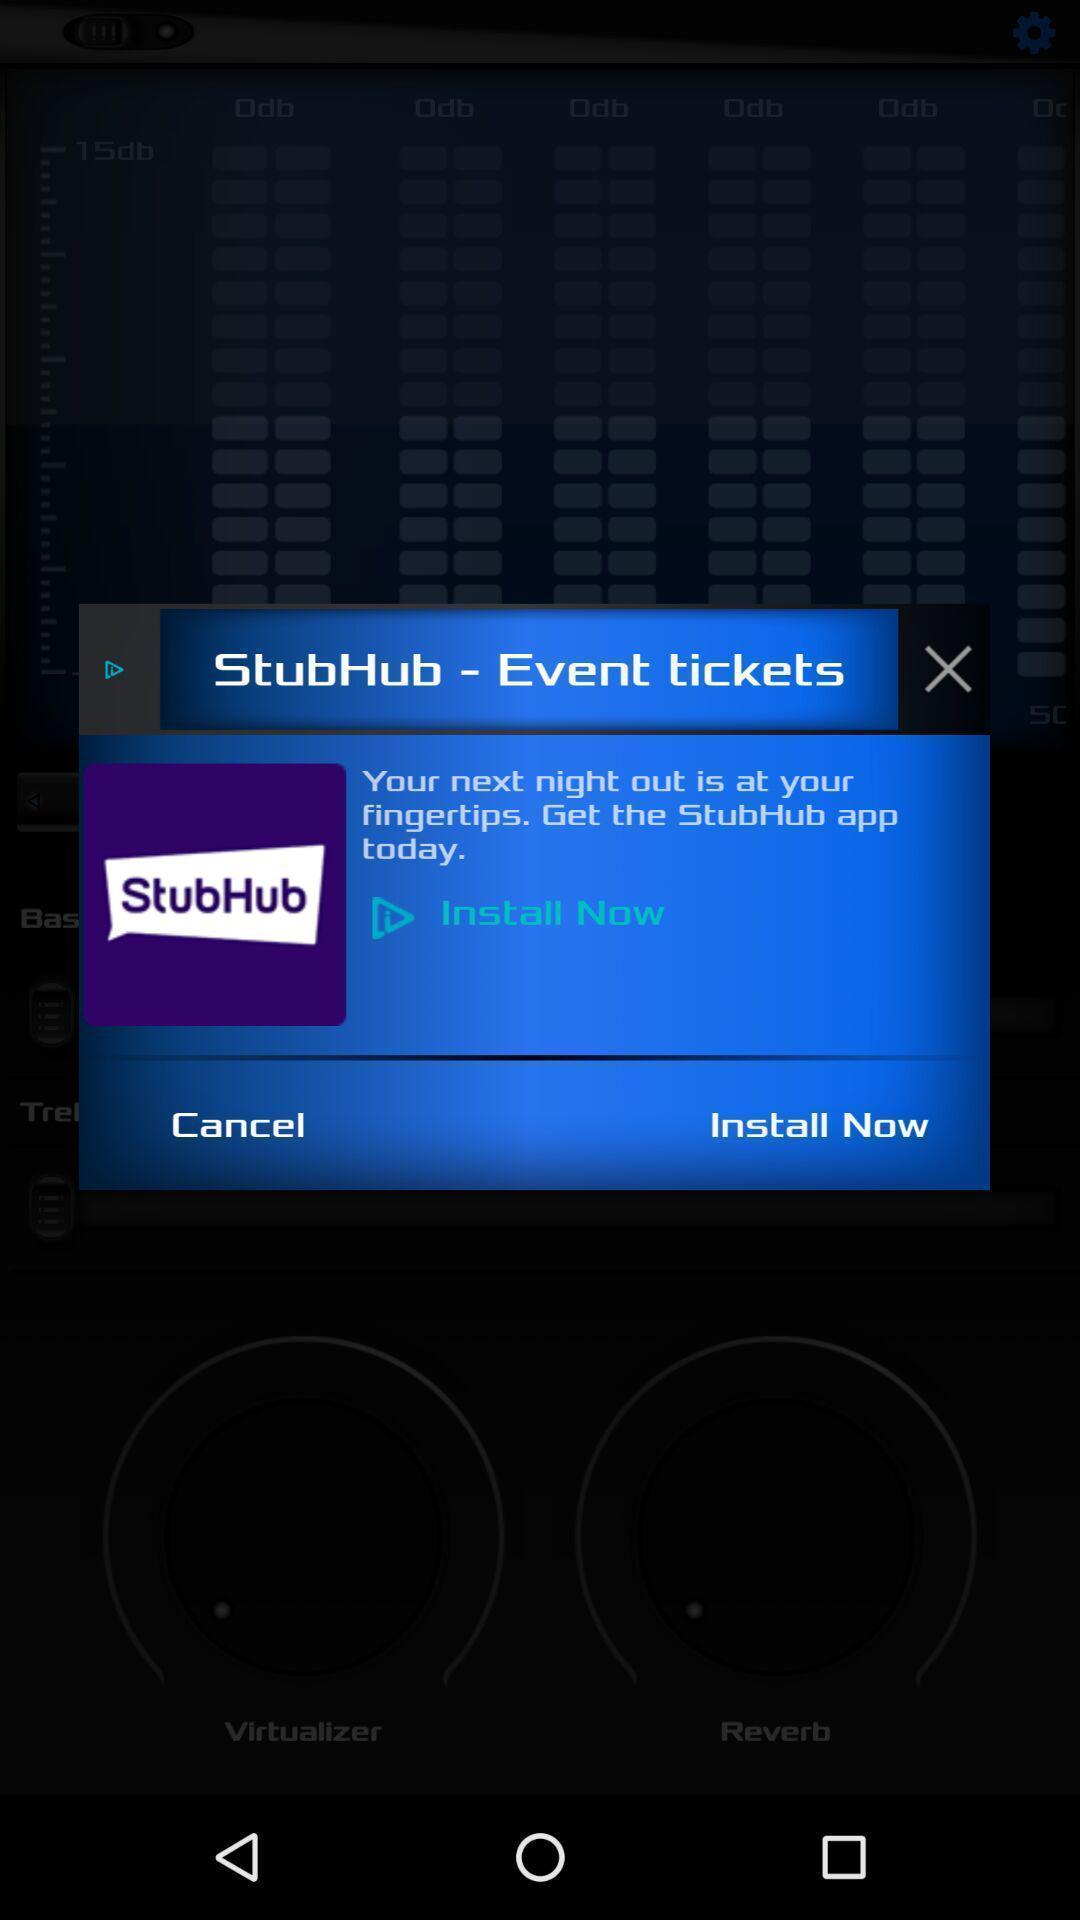What details can you identify in this image? Pop-up to install now. 